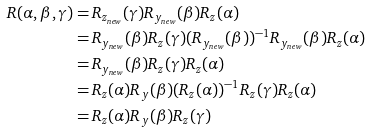Convert formula to latex. <formula><loc_0><loc_0><loc_500><loc_500>R ( \alpha , \beta , \gamma ) = & \, R _ { z _ { n e w } } ( \gamma ) R _ { y _ { n e w } } ( \beta ) R _ { z } ( \alpha ) \\ = & \, R _ { y _ { n e w } } ( \beta ) R _ { z } ( \gamma ) ( R _ { y _ { n e w } } ( \beta ) ) ^ { - 1 } R _ { y _ { n e w } } ( \beta ) R _ { z } ( \alpha ) \\ = & \, R _ { y _ { n e w } } ( \beta ) R _ { z } ( \gamma ) R _ { z } ( \alpha ) \\ = & \, R _ { z } ( \alpha ) R _ { y } ( \beta ) ( R _ { z } ( \alpha ) ) ^ { - 1 } R _ { z } ( \gamma ) R _ { z } ( \alpha ) \\ = & \, R _ { z } ( \alpha ) R _ { y } ( \beta ) R _ { z } ( \gamma )</formula> 